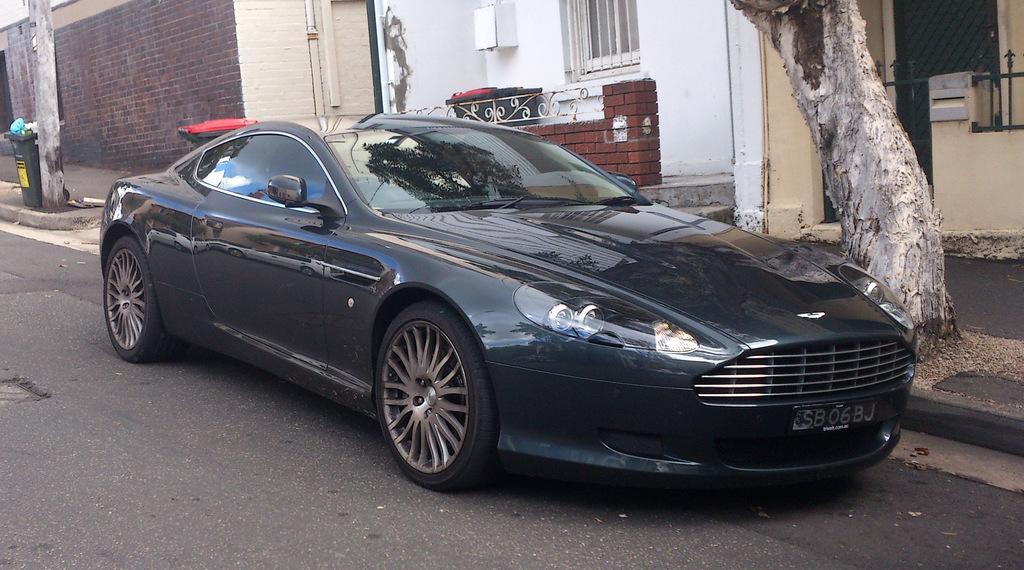How would you summarize this image in a sentence or two? This picture is clicked outside. In the center there is a black color car parked on the ground. In the background we can see the buildings, window, door, trunk of a tree and some other items. 